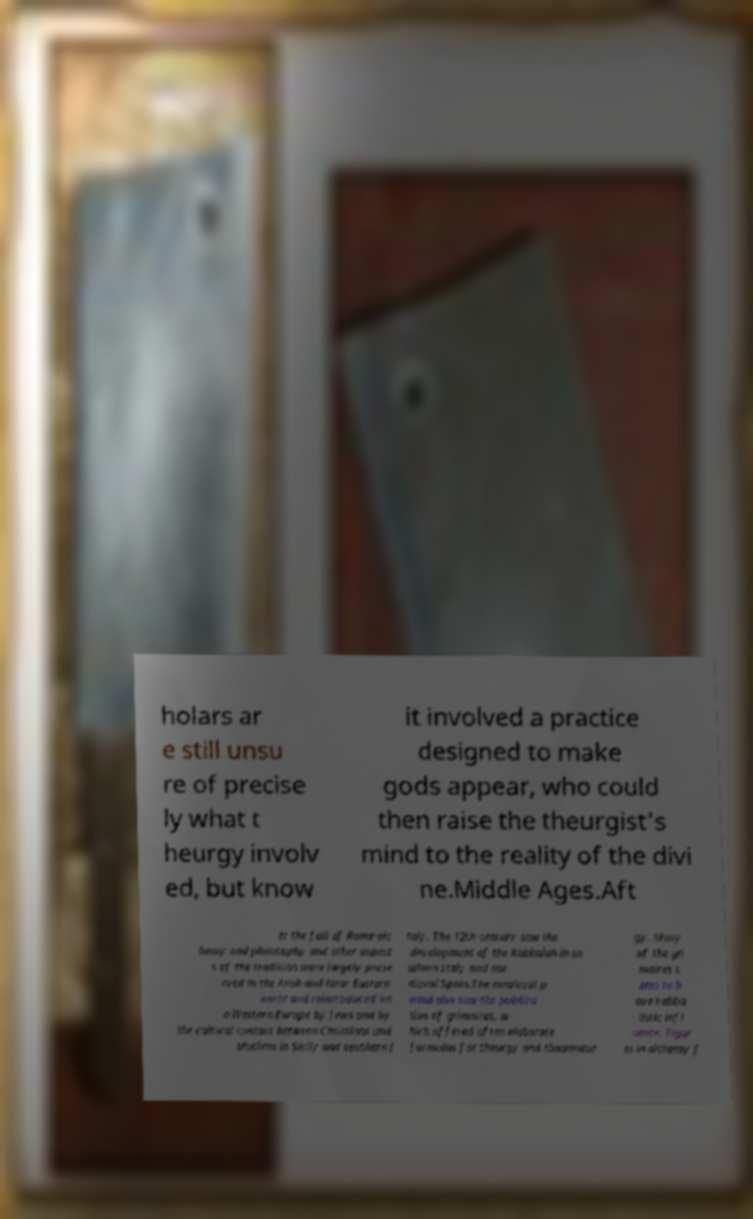What messages or text are displayed in this image? I need them in a readable, typed format. holars ar e still unsu re of precise ly what t heurgy involv ed, but know it involved a practice designed to make gods appear, who could then raise the theurgist's mind to the reality of the divi ne.Middle Ages.Aft er the fall of Rome alc hemy and philosophy and other aspect s of the tradition were largely prese rved in the Arab and Near Eastern world and reintroduced int o Western Europe by Jews and by the cultural contact between Christians and Muslims in Sicily and southern I taly. The 12th century saw the development of the Kabbalah in so uthern Italy and me dieval Spain.The medieval p eriod also saw the publica tion of grimoires, w hich offered often elaborate formulas for theurgy and thaumatur gy. Many of the gri moires s eem to h ave kabba listic infl uence. Figur es in alchemy f 